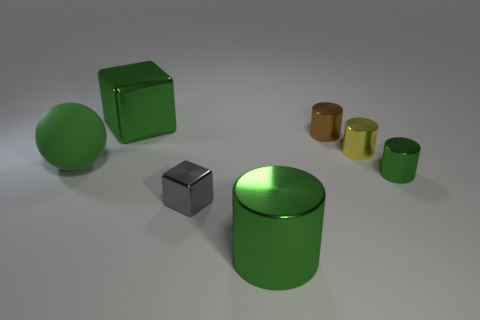Add 2 blue shiny spheres. How many objects exist? 9 Subtract all cubes. How many objects are left? 5 Add 1 small yellow cubes. How many small yellow cubes exist? 1 Subtract 1 green cubes. How many objects are left? 6 Subtract all cubes. Subtract all large gray cylinders. How many objects are left? 5 Add 7 big green rubber objects. How many big green rubber objects are left? 8 